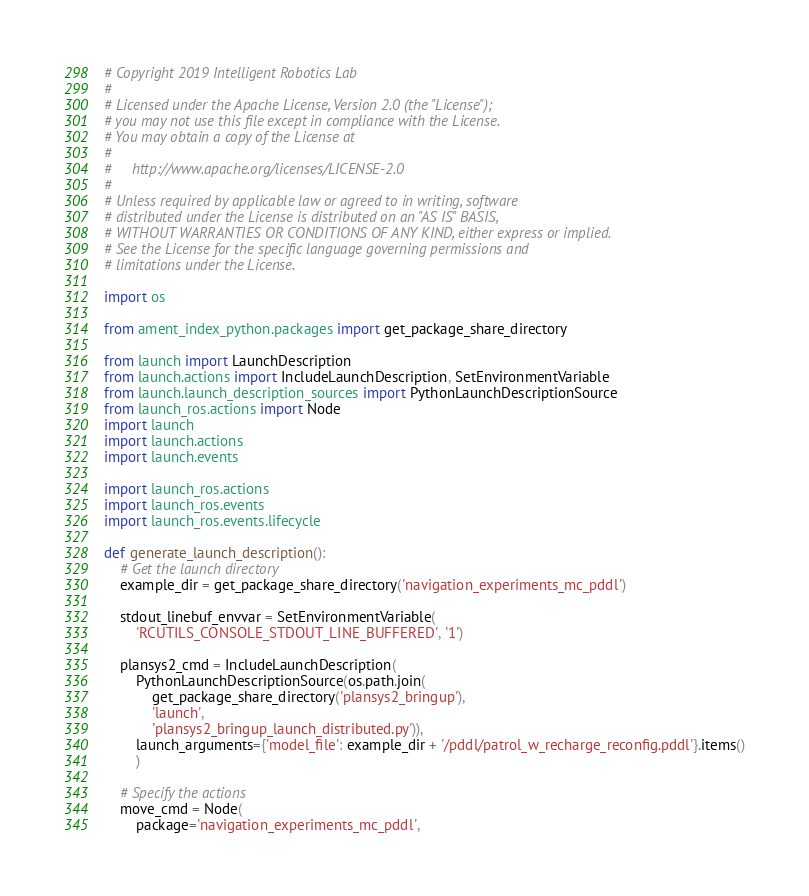Convert code to text. <code><loc_0><loc_0><loc_500><loc_500><_Python_># Copyright 2019 Intelligent Robotics Lab
#
# Licensed under the Apache License, Version 2.0 (the "License");
# you may not use this file except in compliance with the License.
# You may obtain a copy of the License at
#
#     http://www.apache.org/licenses/LICENSE-2.0
#
# Unless required by applicable law or agreed to in writing, software
# distributed under the License is distributed on an "AS IS" BASIS,
# WITHOUT WARRANTIES OR CONDITIONS OF ANY KIND, either express or implied.
# See the License for the specific language governing permissions and
# limitations under the License.

import os

from ament_index_python.packages import get_package_share_directory

from launch import LaunchDescription
from launch.actions import IncludeLaunchDescription, SetEnvironmentVariable
from launch.launch_description_sources import PythonLaunchDescriptionSource
from launch_ros.actions import Node
import launch
import launch.actions
import launch.events

import launch_ros.actions
import launch_ros.events
import launch_ros.events.lifecycle

def generate_launch_description():
    # Get the launch directory
    example_dir = get_package_share_directory('navigation_experiments_mc_pddl')

    stdout_linebuf_envvar = SetEnvironmentVariable(
        'RCUTILS_CONSOLE_STDOUT_LINE_BUFFERED', '1')

    plansys2_cmd = IncludeLaunchDescription(
        PythonLaunchDescriptionSource(os.path.join(
            get_package_share_directory('plansys2_bringup'),
            'launch',
            'plansys2_bringup_launch_distributed.py')),
        launch_arguments={'model_file': example_dir + '/pddl/patrol_w_recharge_reconfig.pddl'}.items()
        )

    # Specify the actions
    move_cmd = Node(
        package='navigation_experiments_mc_pddl',</code> 